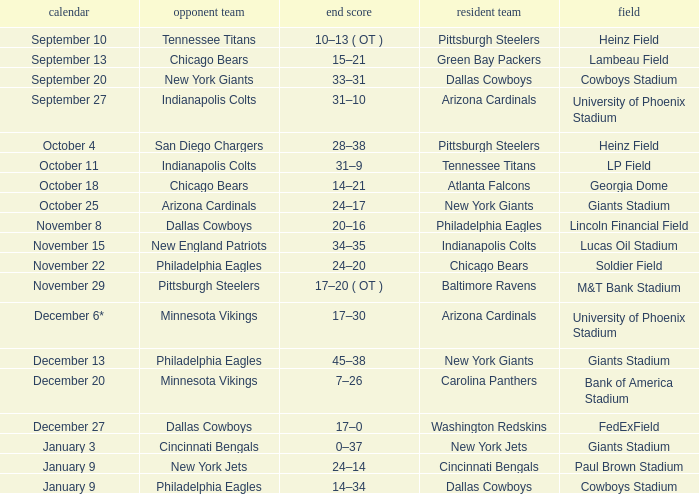I want to know the stadium for tennessee titans visiting Heinz Field. 